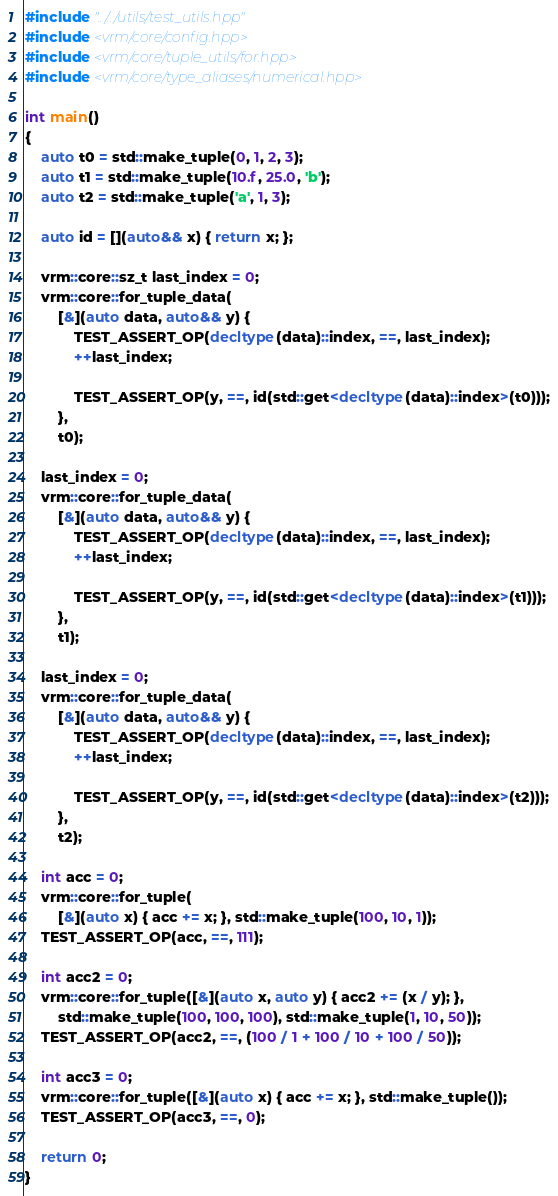Convert code to text. <code><loc_0><loc_0><loc_500><loc_500><_C++_>#include "../../utils/test_utils.hpp"
#include <vrm/core/config.hpp>
#include <vrm/core/tuple_utils/for.hpp>
#include <vrm/core/type_aliases/numerical.hpp>

int main()
{
    auto t0 = std::make_tuple(0, 1, 2, 3);
    auto t1 = std::make_tuple(10.f, 25.0, 'b');
    auto t2 = std::make_tuple('a', 1, 3);

    auto id = [](auto&& x) { return x; };

    vrm::core::sz_t last_index = 0;
    vrm::core::for_tuple_data(
        [&](auto data, auto&& y) {
            TEST_ASSERT_OP(decltype(data)::index, ==, last_index);
            ++last_index;

            TEST_ASSERT_OP(y, ==, id(std::get<decltype(data)::index>(t0)));
        },
        t0);

    last_index = 0;
    vrm::core::for_tuple_data(
        [&](auto data, auto&& y) {
            TEST_ASSERT_OP(decltype(data)::index, ==, last_index);
            ++last_index;

            TEST_ASSERT_OP(y, ==, id(std::get<decltype(data)::index>(t1)));
        },
        t1);

    last_index = 0;
    vrm::core::for_tuple_data(
        [&](auto data, auto&& y) {
            TEST_ASSERT_OP(decltype(data)::index, ==, last_index);
            ++last_index;

            TEST_ASSERT_OP(y, ==, id(std::get<decltype(data)::index>(t2)));
        },
        t2);

    int acc = 0;
    vrm::core::for_tuple(
        [&](auto x) { acc += x; }, std::make_tuple(100, 10, 1));
    TEST_ASSERT_OP(acc, ==, 111);

    int acc2 = 0;
    vrm::core::for_tuple([&](auto x, auto y) { acc2 += (x / y); },
        std::make_tuple(100, 100, 100), std::make_tuple(1, 10, 50));
    TEST_ASSERT_OP(acc2, ==, (100 / 1 + 100 / 10 + 100 / 50));

    int acc3 = 0;
    vrm::core::for_tuple([&](auto x) { acc += x; }, std::make_tuple());
    TEST_ASSERT_OP(acc3, ==, 0);

    return 0;
}
</code> 